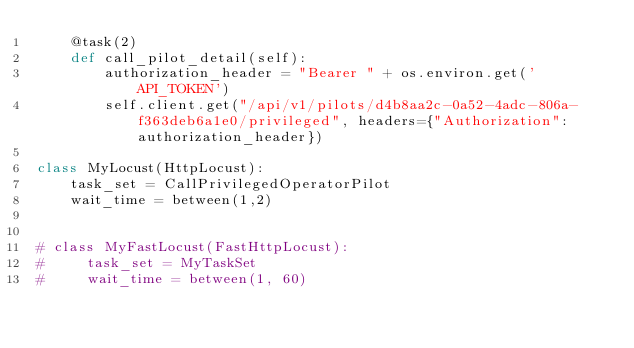Convert code to text. <code><loc_0><loc_0><loc_500><loc_500><_Python_>    @task(2)
    def call_pilot_detail(self):
        authorization_header = "Bearer " + os.environ.get('API_TOKEN')
        self.client.get("/api/v1/pilots/d4b8aa2c-0a52-4adc-806a-f363deb6a1e0/privileged", headers={"Authorization":authorization_header})

class MyLocust(HttpLocust):
    task_set = CallPrivilegedOperatorPilot
    wait_time = between(1,2)


# class MyFastLocust(FastHttpLocust):
#     task_set = MyTaskSet
#     wait_time = between(1, 60)</code> 